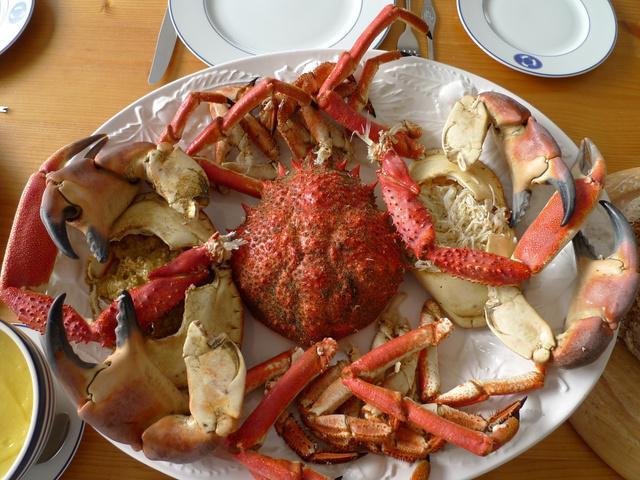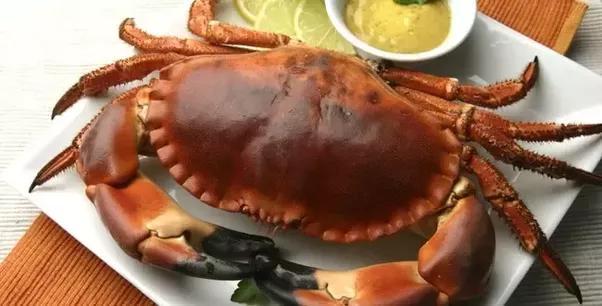The first image is the image on the left, the second image is the image on the right. Analyze the images presented: Is the assertion "One image contains a single red-orange crab with an intact red-orange shell and claws, and the other image includes multiple crabs on a white container surface." valid? Answer yes or no. Yes. The first image is the image on the left, the second image is the image on the right. Analyze the images presented: Is the assertion "At least one of the crabs has black tipped pincers." valid? Answer yes or no. Yes. 